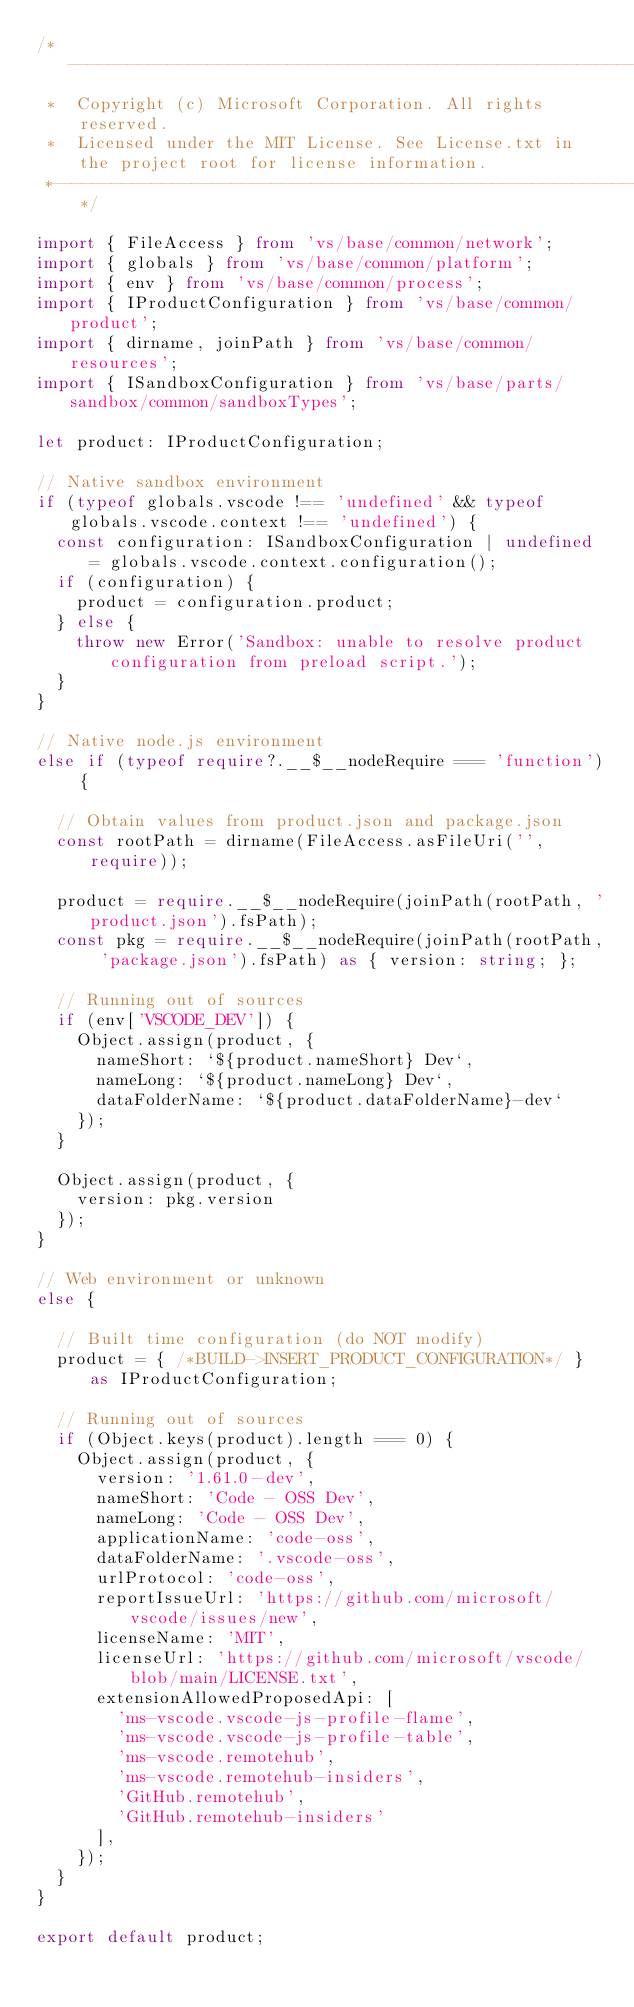<code> <loc_0><loc_0><loc_500><loc_500><_TypeScript_>/*---------------------------------------------------------------------------------------------
 *  Copyright (c) Microsoft Corporation. All rights reserved.
 *  Licensed under the MIT License. See License.txt in the project root for license information.
 *--------------------------------------------------------------------------------------------*/

import { FileAccess } from 'vs/base/common/network';
import { globals } from 'vs/base/common/platform';
import { env } from 'vs/base/common/process';
import { IProductConfiguration } from 'vs/base/common/product';
import { dirname, joinPath } from 'vs/base/common/resources';
import { ISandboxConfiguration } from 'vs/base/parts/sandbox/common/sandboxTypes';

let product: IProductConfiguration;

// Native sandbox environment
if (typeof globals.vscode !== 'undefined' && typeof globals.vscode.context !== 'undefined') {
	const configuration: ISandboxConfiguration | undefined = globals.vscode.context.configuration();
	if (configuration) {
		product = configuration.product;
	} else {
		throw new Error('Sandbox: unable to resolve product configuration from preload script.');
	}
}

// Native node.js environment
else if (typeof require?.__$__nodeRequire === 'function') {

	// Obtain values from product.json and package.json
	const rootPath = dirname(FileAccess.asFileUri('', require));

	product = require.__$__nodeRequire(joinPath(rootPath, 'product.json').fsPath);
	const pkg = require.__$__nodeRequire(joinPath(rootPath, 'package.json').fsPath) as { version: string; };

	// Running out of sources
	if (env['VSCODE_DEV']) {
		Object.assign(product, {
			nameShort: `${product.nameShort} Dev`,
			nameLong: `${product.nameLong} Dev`,
			dataFolderName: `${product.dataFolderName}-dev`
		});
	}

	Object.assign(product, {
		version: pkg.version
	});
}

// Web environment or unknown
else {

	// Built time configuration (do NOT modify)
	product = { /*BUILD->INSERT_PRODUCT_CONFIGURATION*/ } as IProductConfiguration;

	// Running out of sources
	if (Object.keys(product).length === 0) {
		Object.assign(product, {
			version: '1.61.0-dev',
			nameShort: 'Code - OSS Dev',
			nameLong: 'Code - OSS Dev',
			applicationName: 'code-oss',
			dataFolderName: '.vscode-oss',
			urlProtocol: 'code-oss',
			reportIssueUrl: 'https://github.com/microsoft/vscode/issues/new',
			licenseName: 'MIT',
			licenseUrl: 'https://github.com/microsoft/vscode/blob/main/LICENSE.txt',
			extensionAllowedProposedApi: [
				'ms-vscode.vscode-js-profile-flame',
				'ms-vscode.vscode-js-profile-table',
				'ms-vscode.remotehub',
				'ms-vscode.remotehub-insiders',
				'GitHub.remotehub',
				'GitHub.remotehub-insiders'
			],
		});
	}
}

export default product;
</code> 